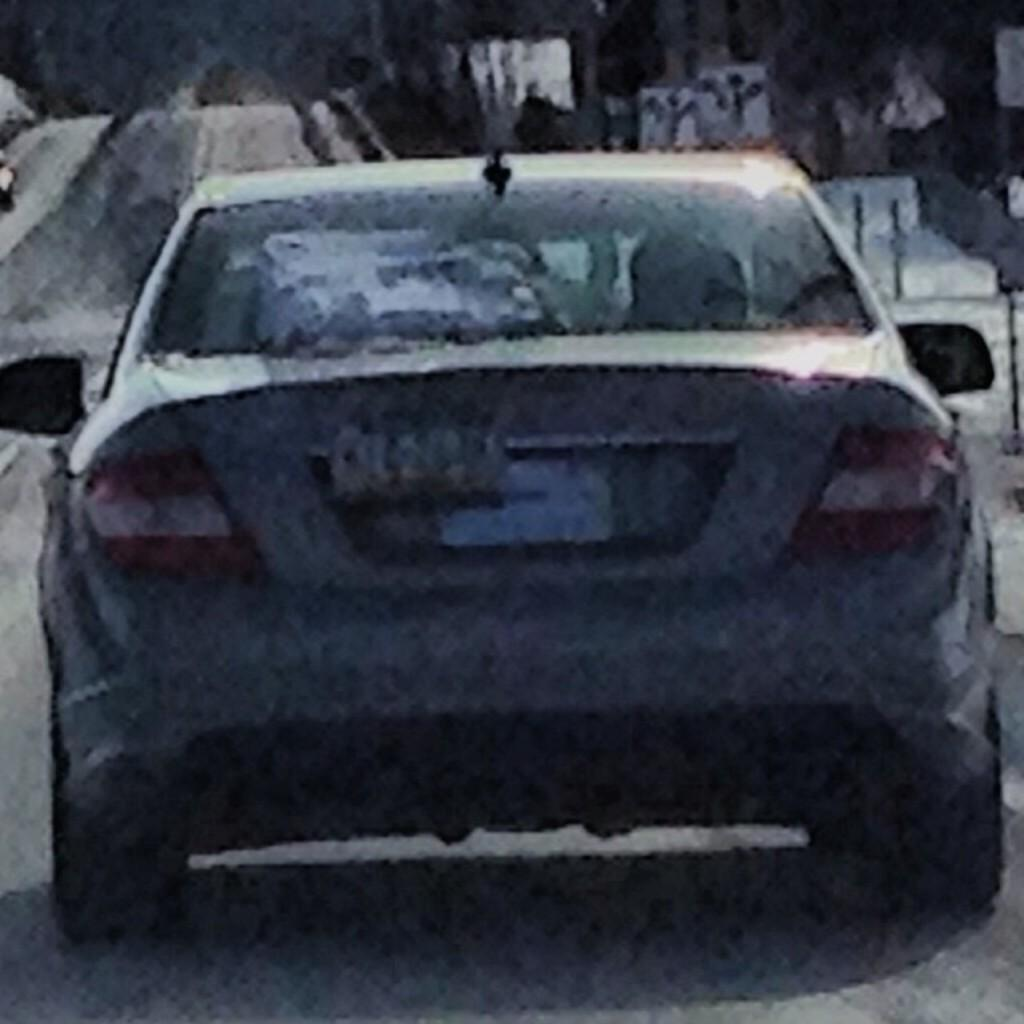What is the main subject in the center of the image? There is a car in the center of the image. What can be seen in the background of the image? There are trees and some objects in the background of the image. What is located at the bottom of the image? There is a walkway at the bottom of the image. How many times does the car fall over in the image? The car does not fall over in the image; it is stationary and upright. What is the size of the place where the car is located? The provided facts do not give information about the size of the place where the car is located. 